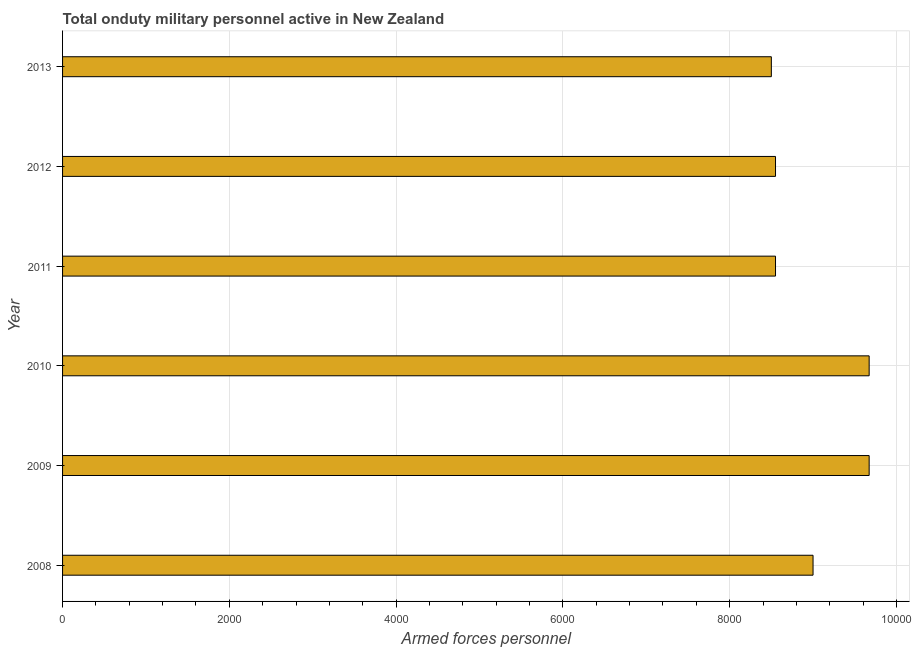Does the graph contain grids?
Your response must be concise. Yes. What is the title of the graph?
Your answer should be very brief. Total onduty military personnel active in New Zealand. What is the label or title of the X-axis?
Provide a succinct answer. Armed forces personnel. What is the label or title of the Y-axis?
Provide a succinct answer. Year. What is the number of armed forces personnel in 2010?
Give a very brief answer. 9673. Across all years, what is the maximum number of armed forces personnel?
Provide a short and direct response. 9673. Across all years, what is the minimum number of armed forces personnel?
Offer a terse response. 8500. In which year was the number of armed forces personnel maximum?
Your response must be concise. 2009. In which year was the number of armed forces personnel minimum?
Provide a short and direct response. 2013. What is the sum of the number of armed forces personnel?
Offer a terse response. 5.39e+04. What is the difference between the number of armed forces personnel in 2008 and 2012?
Give a very brief answer. 450. What is the average number of armed forces personnel per year?
Make the answer very short. 8991. What is the median number of armed forces personnel?
Provide a succinct answer. 8775. What is the ratio of the number of armed forces personnel in 2012 to that in 2013?
Your answer should be very brief. 1.01. Is the difference between the number of armed forces personnel in 2009 and 2012 greater than the difference between any two years?
Provide a short and direct response. No. What is the difference between the highest and the second highest number of armed forces personnel?
Your answer should be very brief. 0. Is the sum of the number of armed forces personnel in 2009 and 2013 greater than the maximum number of armed forces personnel across all years?
Your response must be concise. Yes. What is the difference between the highest and the lowest number of armed forces personnel?
Offer a terse response. 1173. In how many years, is the number of armed forces personnel greater than the average number of armed forces personnel taken over all years?
Give a very brief answer. 3. Are all the bars in the graph horizontal?
Your answer should be very brief. Yes. How many years are there in the graph?
Ensure brevity in your answer.  6. What is the Armed forces personnel of 2008?
Your answer should be very brief. 9000. What is the Armed forces personnel in 2009?
Give a very brief answer. 9673. What is the Armed forces personnel in 2010?
Make the answer very short. 9673. What is the Armed forces personnel of 2011?
Keep it short and to the point. 8550. What is the Armed forces personnel in 2012?
Your response must be concise. 8550. What is the Armed forces personnel in 2013?
Give a very brief answer. 8500. What is the difference between the Armed forces personnel in 2008 and 2009?
Your response must be concise. -673. What is the difference between the Armed forces personnel in 2008 and 2010?
Keep it short and to the point. -673. What is the difference between the Armed forces personnel in 2008 and 2011?
Provide a short and direct response. 450. What is the difference between the Armed forces personnel in 2008 and 2012?
Give a very brief answer. 450. What is the difference between the Armed forces personnel in 2009 and 2010?
Your answer should be very brief. 0. What is the difference between the Armed forces personnel in 2009 and 2011?
Give a very brief answer. 1123. What is the difference between the Armed forces personnel in 2009 and 2012?
Your answer should be very brief. 1123. What is the difference between the Armed forces personnel in 2009 and 2013?
Provide a short and direct response. 1173. What is the difference between the Armed forces personnel in 2010 and 2011?
Keep it short and to the point. 1123. What is the difference between the Armed forces personnel in 2010 and 2012?
Your response must be concise. 1123. What is the difference between the Armed forces personnel in 2010 and 2013?
Provide a short and direct response. 1173. What is the difference between the Armed forces personnel in 2012 and 2013?
Offer a very short reply. 50. What is the ratio of the Armed forces personnel in 2008 to that in 2009?
Offer a very short reply. 0.93. What is the ratio of the Armed forces personnel in 2008 to that in 2010?
Provide a succinct answer. 0.93. What is the ratio of the Armed forces personnel in 2008 to that in 2011?
Offer a terse response. 1.05. What is the ratio of the Armed forces personnel in 2008 to that in 2012?
Offer a very short reply. 1.05. What is the ratio of the Armed forces personnel in 2008 to that in 2013?
Offer a terse response. 1.06. What is the ratio of the Armed forces personnel in 2009 to that in 2010?
Offer a terse response. 1. What is the ratio of the Armed forces personnel in 2009 to that in 2011?
Offer a terse response. 1.13. What is the ratio of the Armed forces personnel in 2009 to that in 2012?
Your answer should be compact. 1.13. What is the ratio of the Armed forces personnel in 2009 to that in 2013?
Your response must be concise. 1.14. What is the ratio of the Armed forces personnel in 2010 to that in 2011?
Make the answer very short. 1.13. What is the ratio of the Armed forces personnel in 2010 to that in 2012?
Provide a short and direct response. 1.13. What is the ratio of the Armed forces personnel in 2010 to that in 2013?
Provide a short and direct response. 1.14. What is the ratio of the Armed forces personnel in 2011 to that in 2013?
Give a very brief answer. 1.01. 